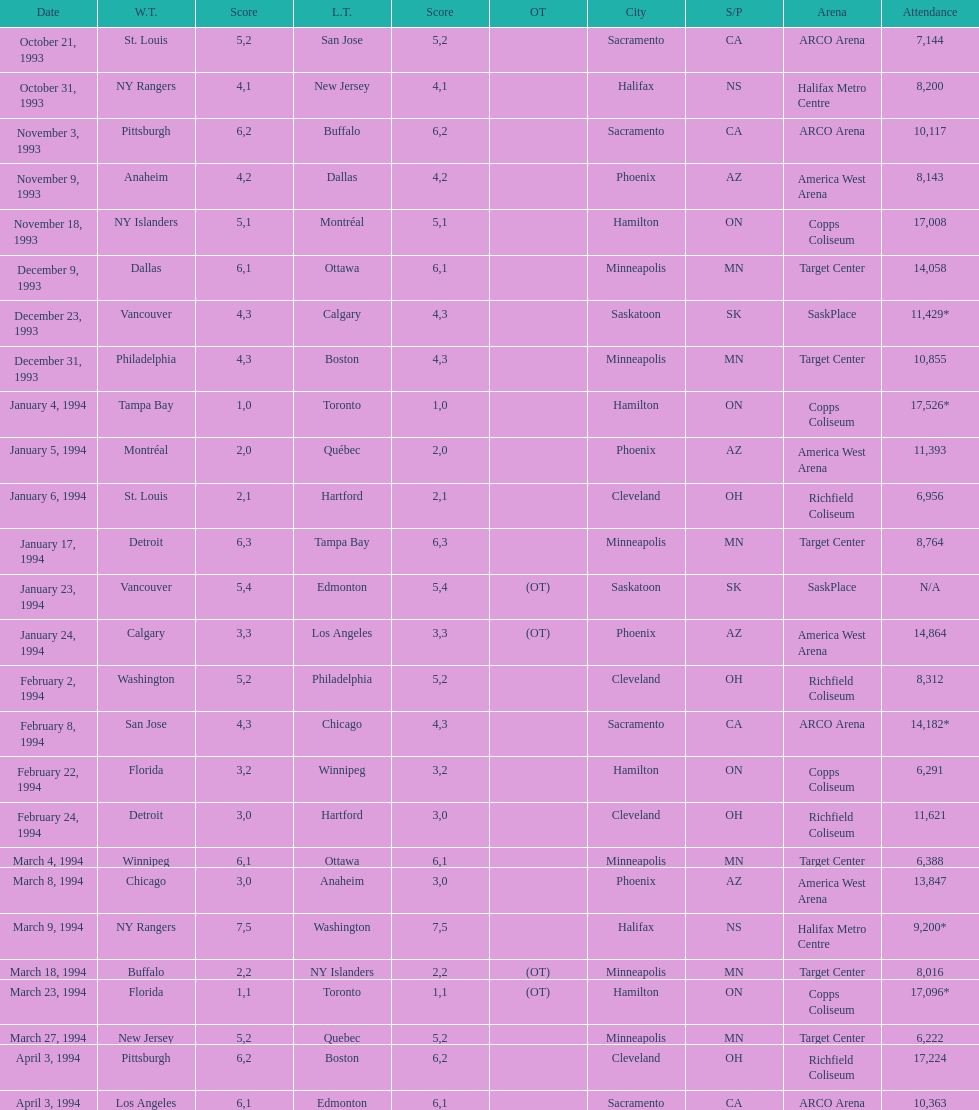How many neutral site games resulted in overtime (ot)? 4. 